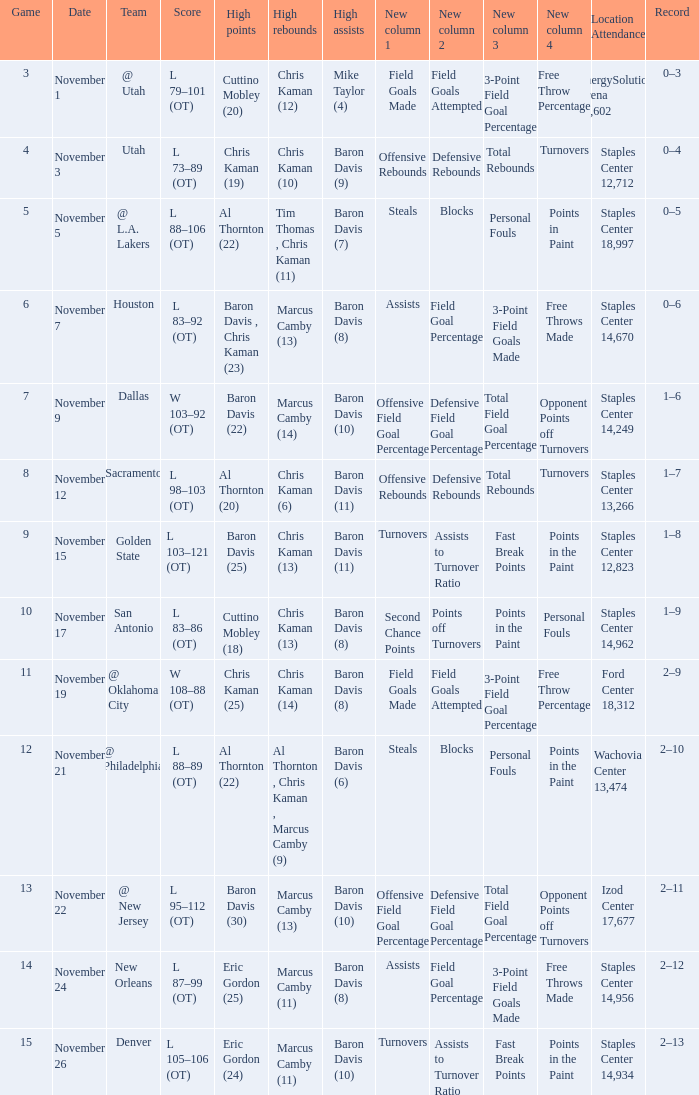Name the high assists for  l 98–103 (ot) Baron Davis (11). 